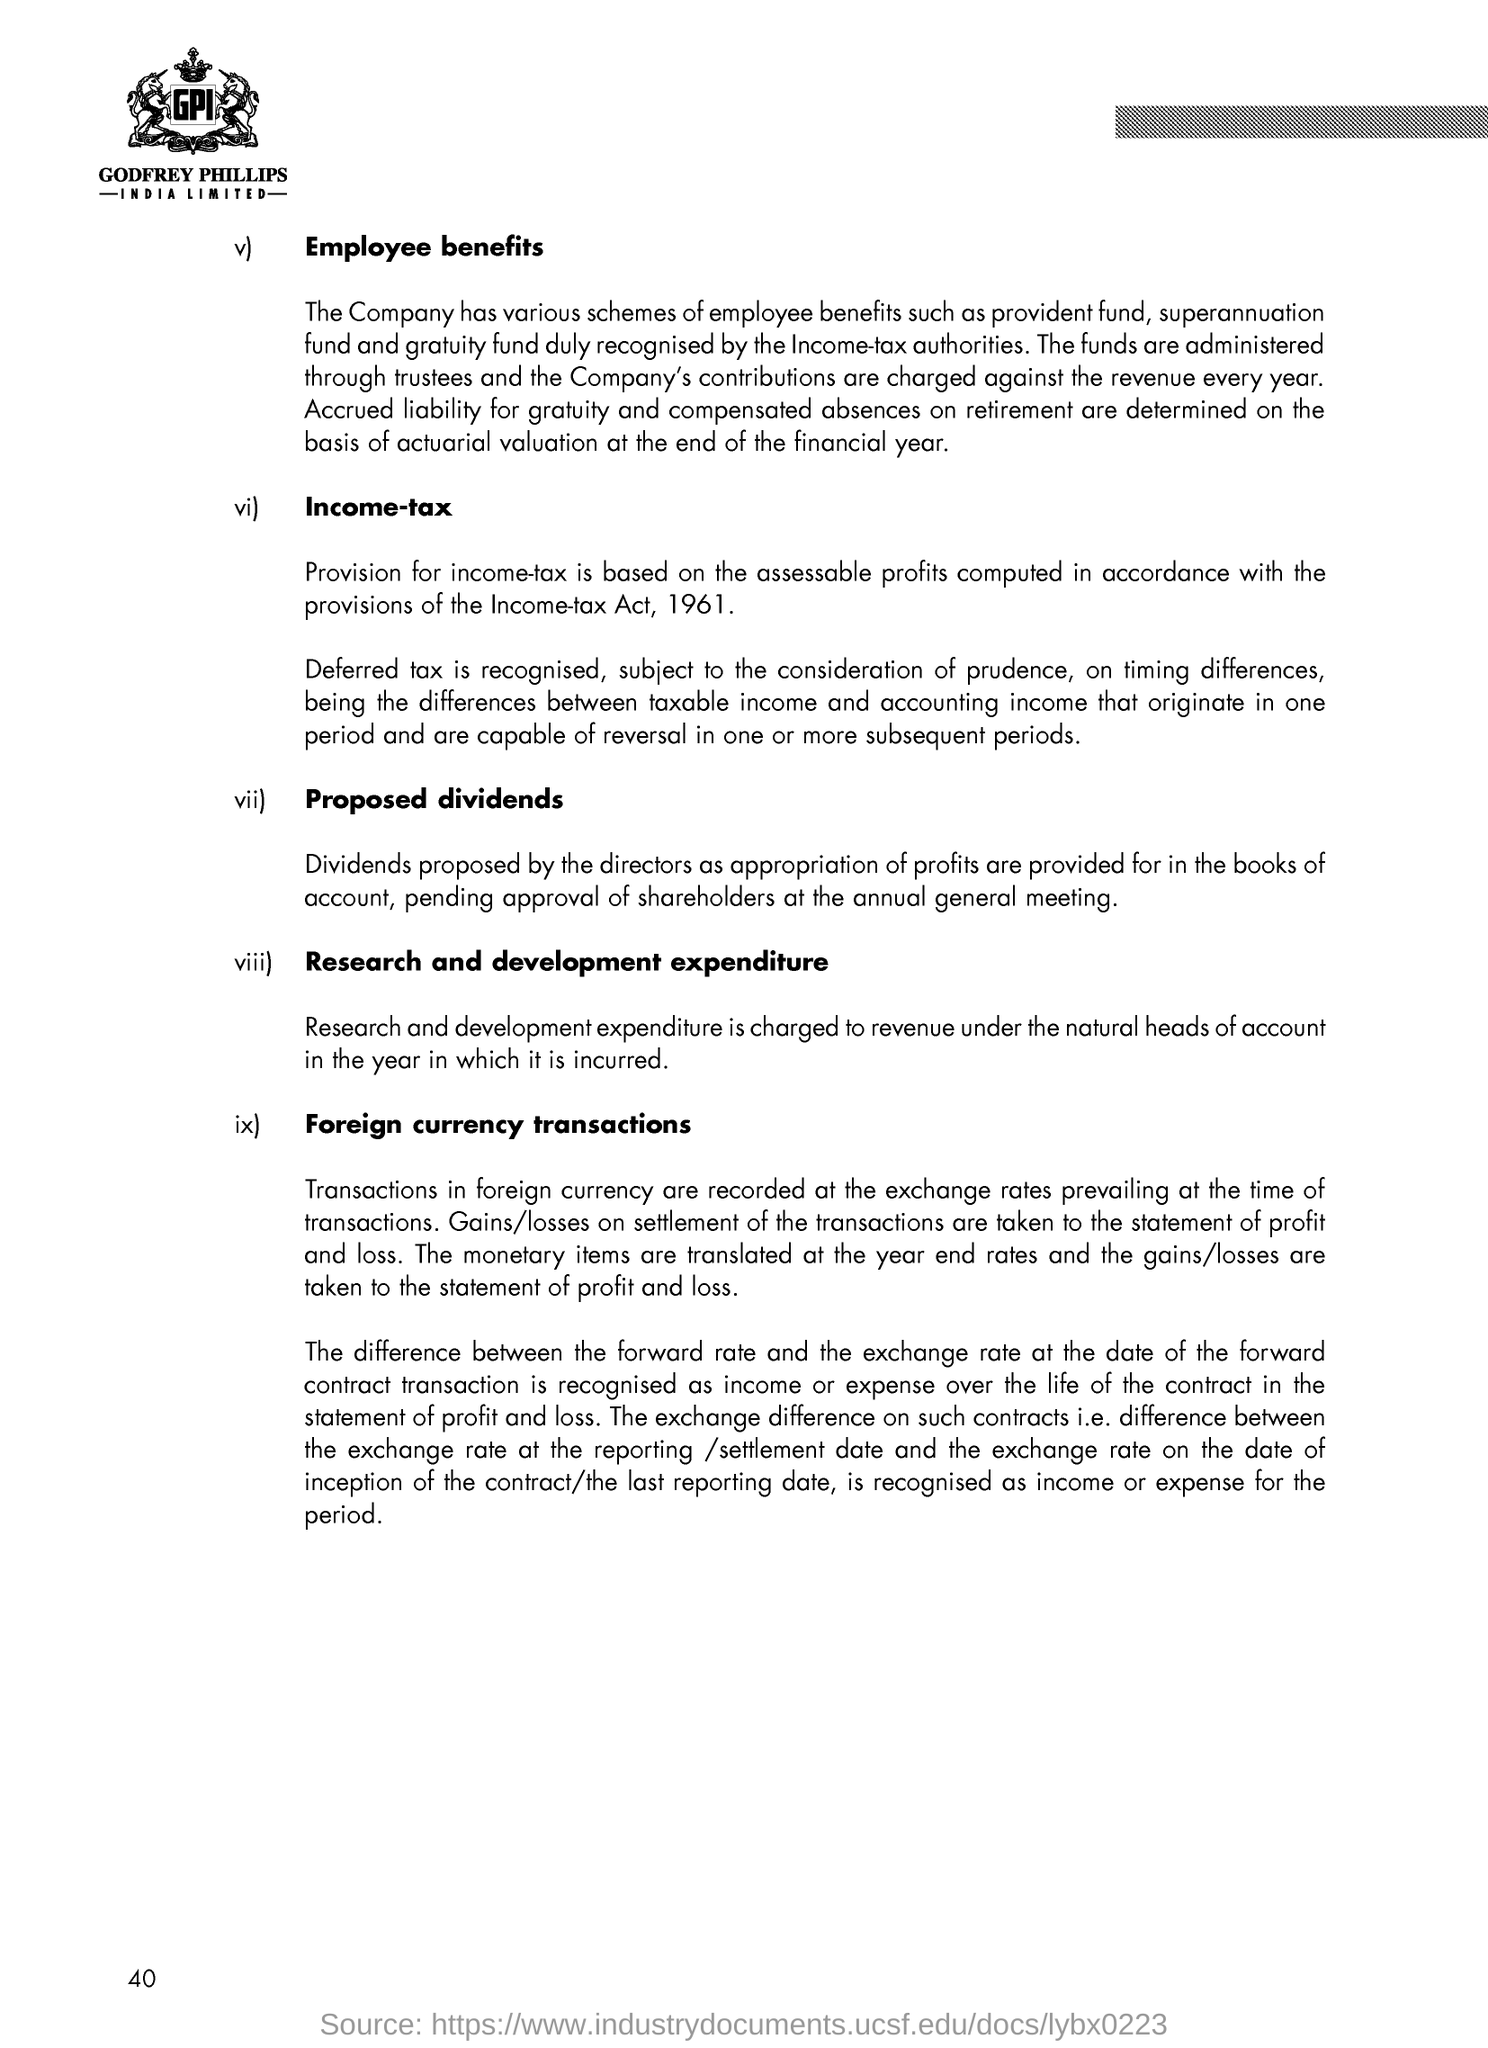Which authority duly recognise the provident fund,superannuation fund and gratuity fund?
Offer a terse response. Income-tax authorities. What all on settlement of the transactions are taken to the statement of profit and loss?
Provide a short and direct response. Gains/losses. Mention the three letter word shown inside the logo on the top of the document?
Give a very brief answer. Gpi. Mention the heading given to the first paragraph?
Keep it short and to the point. Employee benefits. In which year, did the income-tax act was published?
Your response must be concise. 1961. Who proposed the dividends?
Provide a short and direct response. The directors. What was charged by revenue under the natural heads of account in the year?
Offer a very short reply. Research and development expenditure. What was recognized as subject to the consideration of prudence?
Give a very brief answer. Deferred tax. 